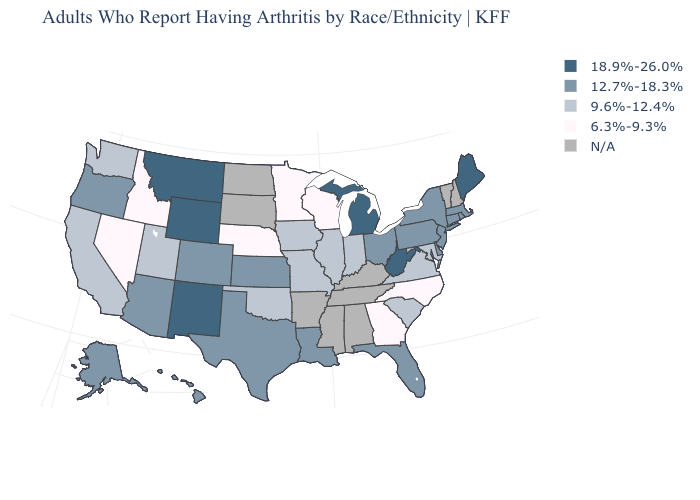Name the states that have a value in the range 9.6%-12.4%?
Be succinct. California, Illinois, Indiana, Iowa, Maryland, Missouri, Oklahoma, South Carolina, Utah, Virginia, Washington. Does the map have missing data?
Concise answer only. Yes. What is the highest value in states that border Kansas?
Quick response, please. 12.7%-18.3%. Name the states that have a value in the range 9.6%-12.4%?
Write a very short answer. California, Illinois, Indiana, Iowa, Maryland, Missouri, Oklahoma, South Carolina, Utah, Virginia, Washington. Name the states that have a value in the range N/A?
Give a very brief answer. Alabama, Arkansas, Kentucky, Mississippi, New Hampshire, North Dakota, South Dakota, Tennessee, Vermont. What is the lowest value in states that border Wyoming?
Give a very brief answer. 6.3%-9.3%. Among the states that border Arizona , does Utah have the highest value?
Keep it brief. No. Among the states that border Colorado , does Nebraska have the lowest value?
Be succinct. Yes. What is the value of Maine?
Write a very short answer. 18.9%-26.0%. Name the states that have a value in the range 18.9%-26.0%?
Give a very brief answer. Maine, Michigan, Montana, New Mexico, West Virginia, Wyoming. Name the states that have a value in the range N/A?
Concise answer only. Alabama, Arkansas, Kentucky, Mississippi, New Hampshire, North Dakota, South Dakota, Tennessee, Vermont. What is the lowest value in the West?
Be succinct. 6.3%-9.3%. Does the first symbol in the legend represent the smallest category?
Answer briefly. No. Among the states that border Wisconsin , which have the highest value?
Write a very short answer. Michigan. What is the value of Colorado?
Concise answer only. 12.7%-18.3%. 